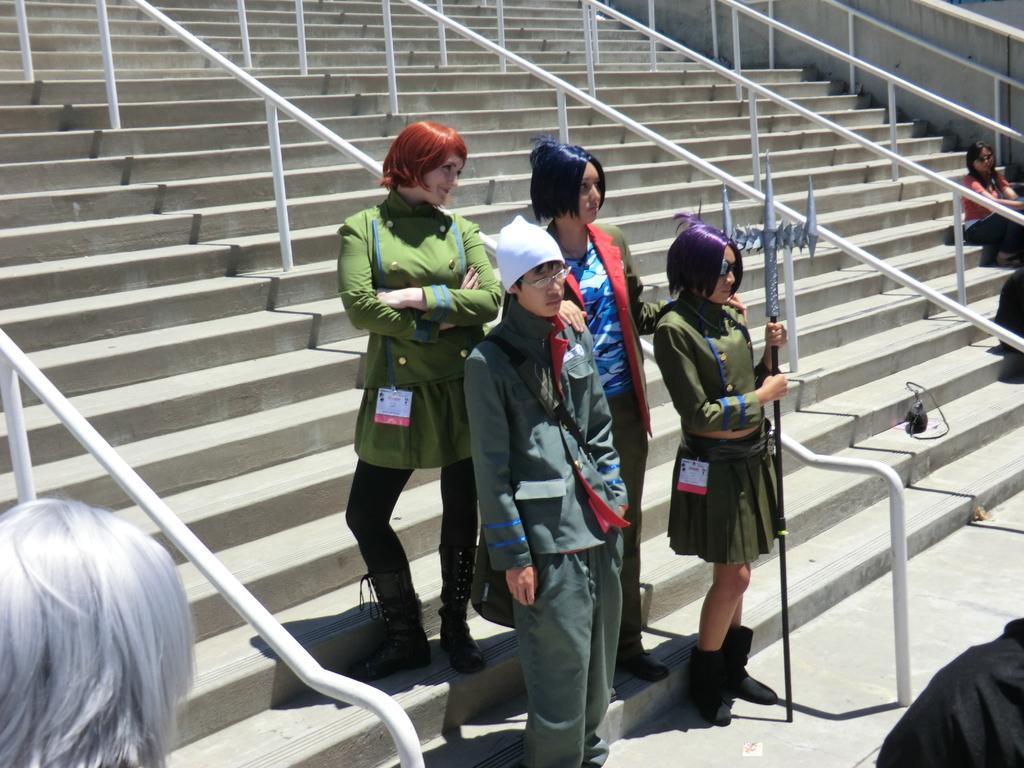Describe this image in one or two sentences. In this image, we can see few people. Few are standing and sitting on the stairs. Few people are wearing glasses. Here we can see a person is holding a weapon. At the bottom, we can see human hair and cloth. Background there are so many stairs, rods. Wall we can see here. 